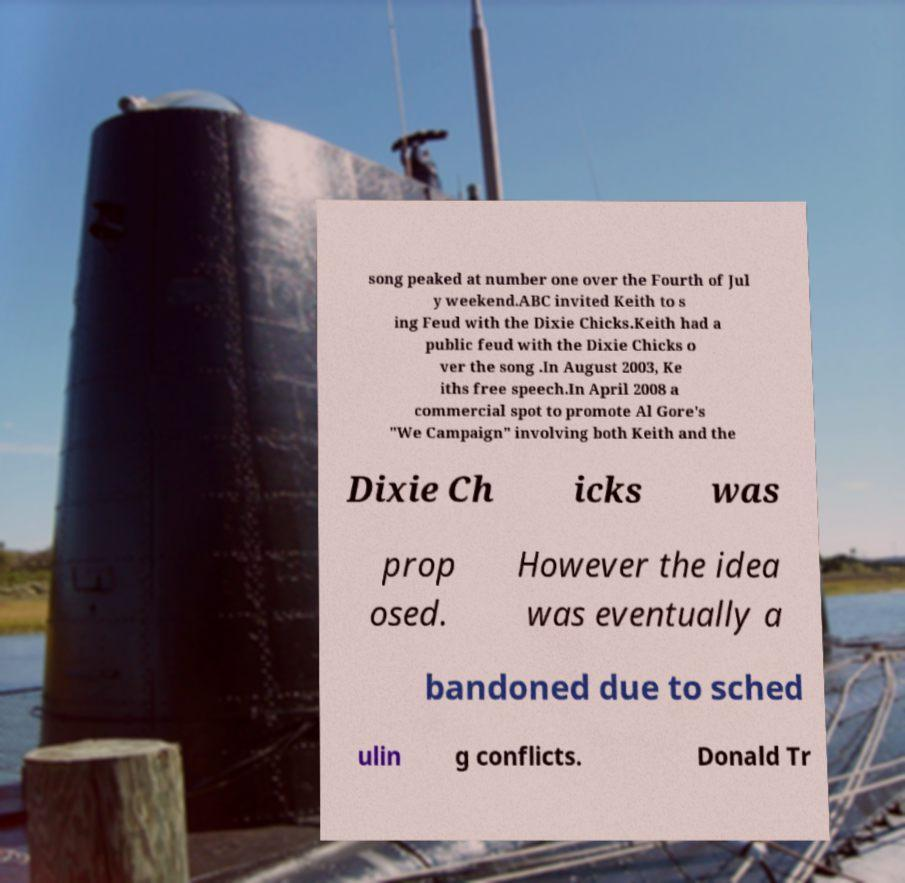There's text embedded in this image that I need extracted. Can you transcribe it verbatim? song peaked at number one over the Fourth of Jul y weekend.ABC invited Keith to s ing Feud with the Dixie Chicks.Keith had a public feud with the Dixie Chicks o ver the song .In August 2003, Ke iths free speech.In April 2008 a commercial spot to promote Al Gore's "We Campaign" involving both Keith and the Dixie Ch icks was prop osed. However the idea was eventually a bandoned due to sched ulin g conflicts. Donald Tr 